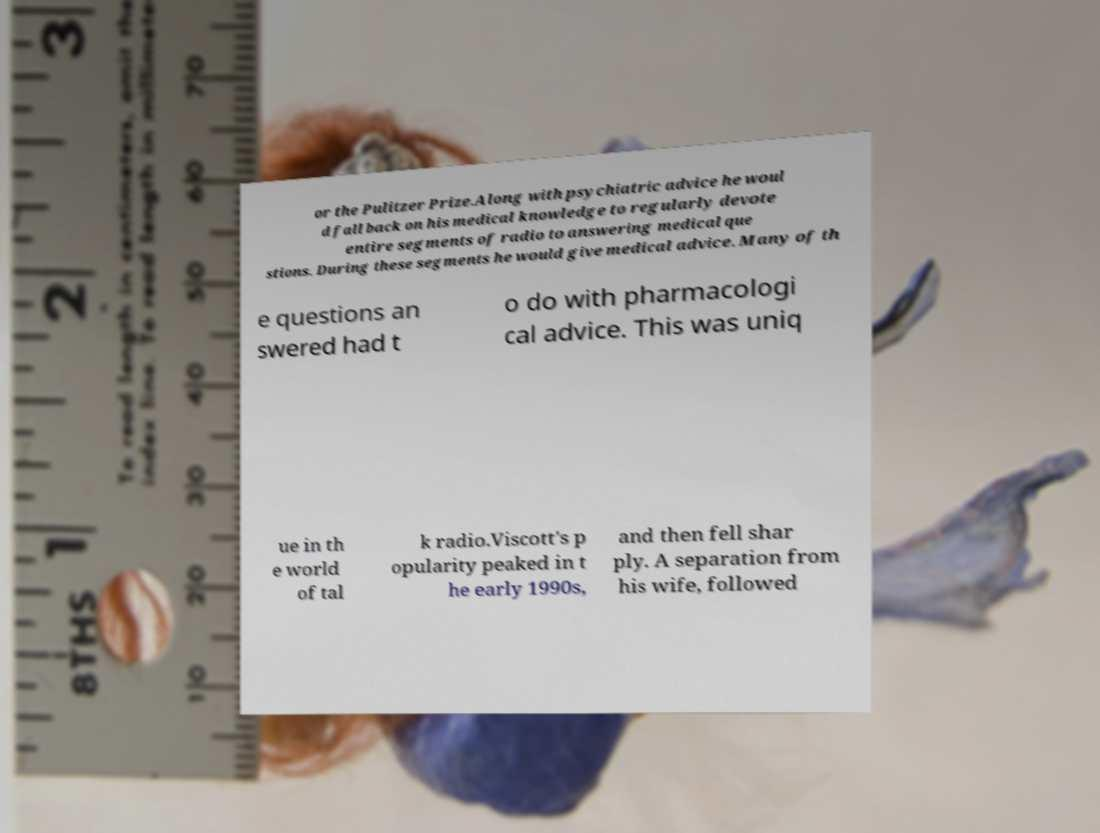What messages or text are displayed in this image? I need them in a readable, typed format. or the Pulitzer Prize.Along with psychiatric advice he woul d fall back on his medical knowledge to regularly devote entire segments of radio to answering medical que stions. During these segments he would give medical advice. Many of th e questions an swered had t o do with pharmacologi cal advice. This was uniq ue in th e world of tal k radio.Viscott's p opularity peaked in t he early 1990s, and then fell shar ply. A separation from his wife, followed 